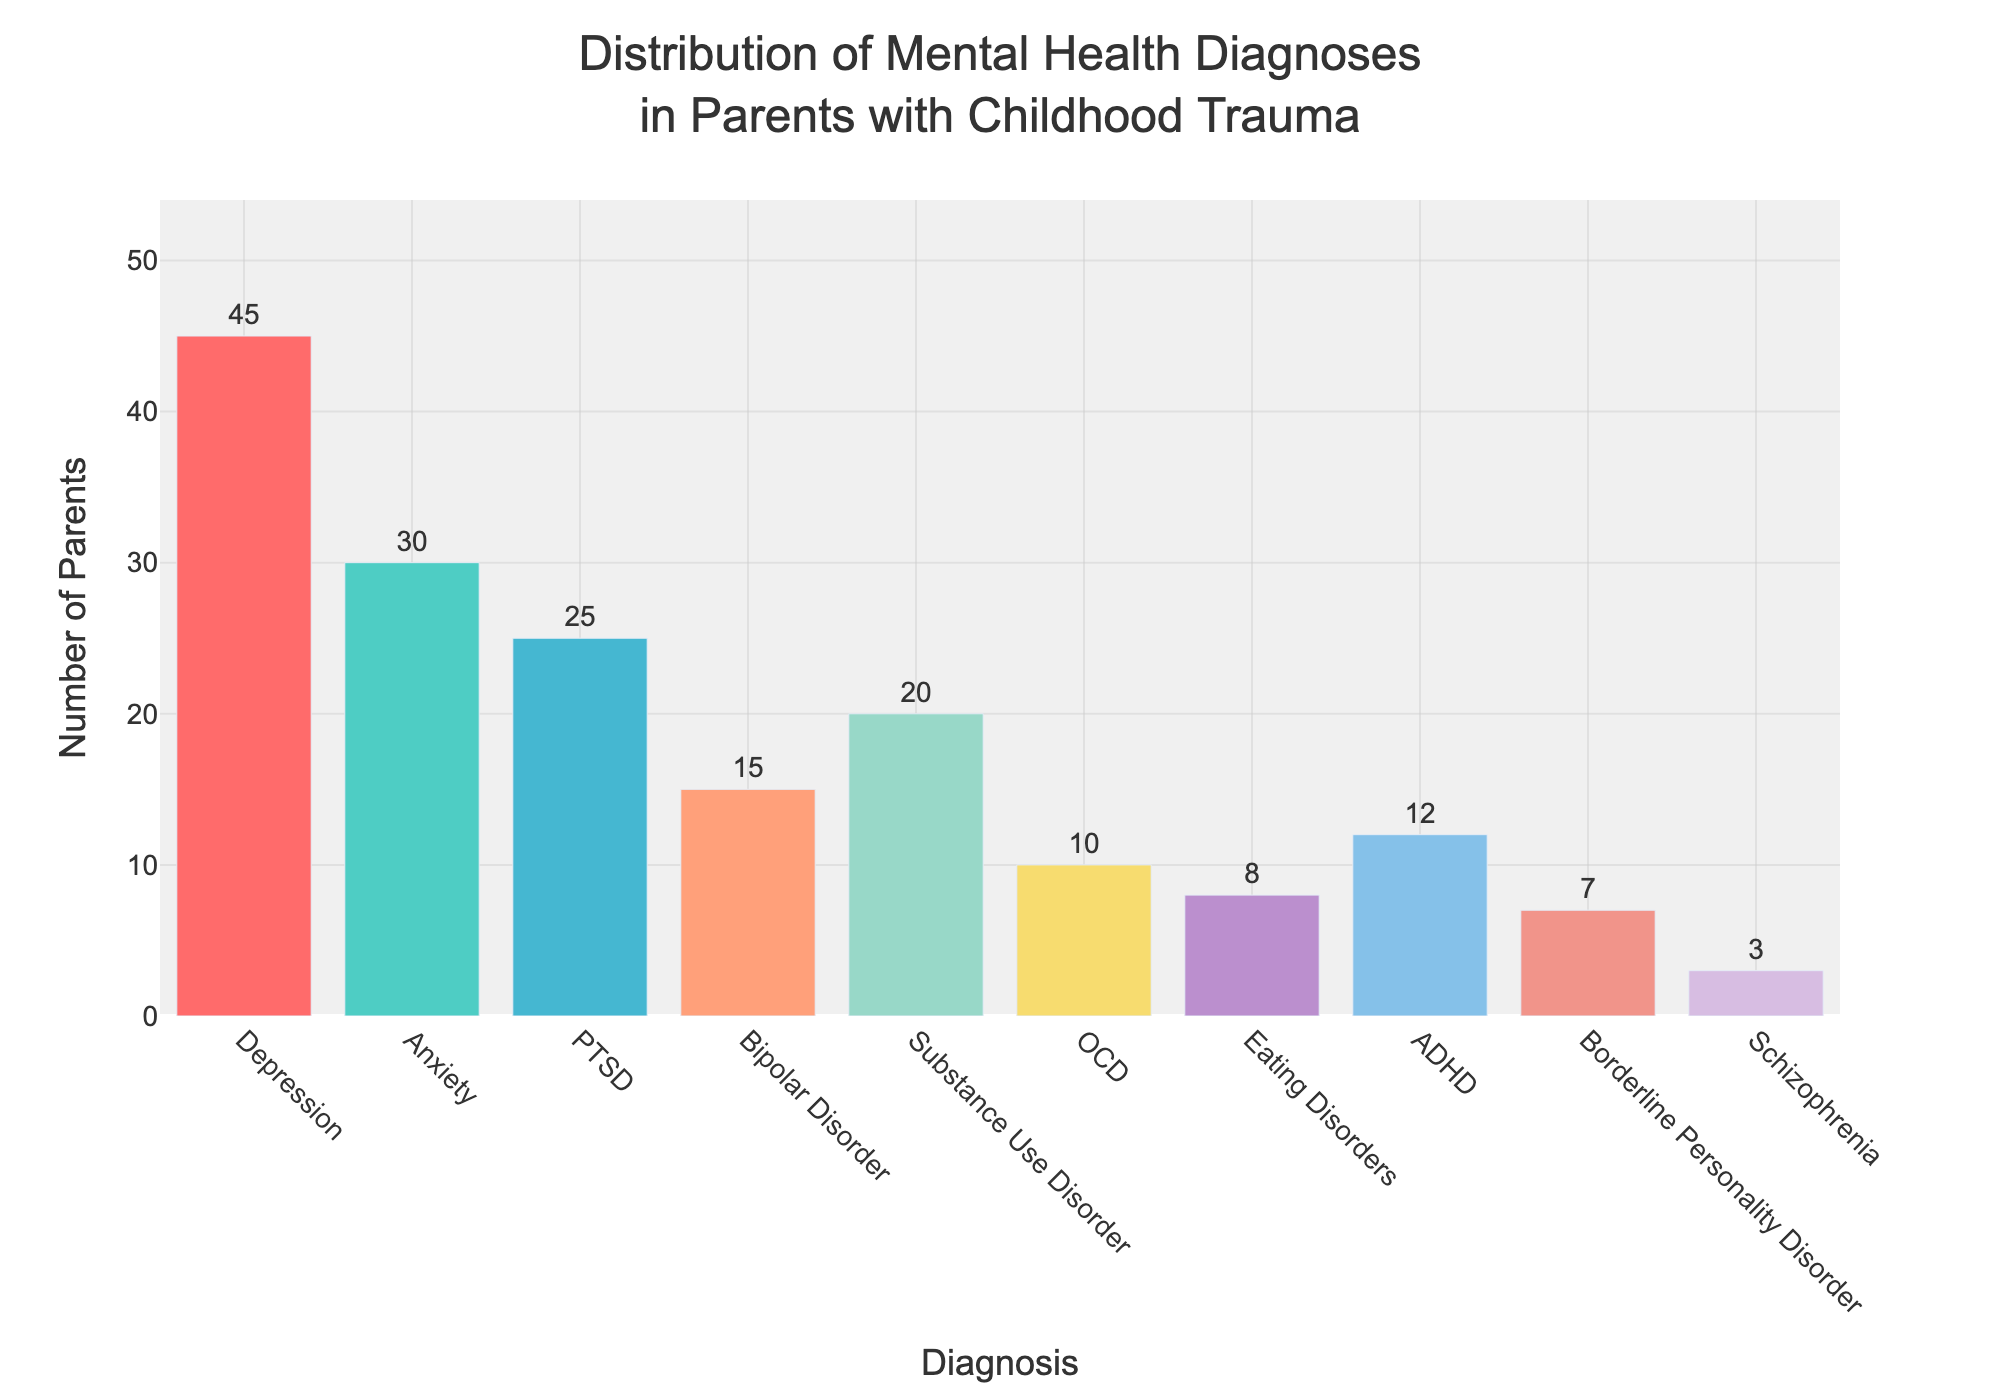What is the most common mental health diagnosis among parents who experienced childhood trauma? The most common mental health diagnosis can be identified by looking at the bar with the highest count. The bar labeled "Depression" is the tallest with a count of 45.
Answer: Depression How many diagnoses have a count of 20 or more parents? By examining the bars, we identify those with counts reaching or exceeding 20. These are "Depression" (45), "Anxiety" (30), PTSD (25), and "Substance Use Disorder" (20). There are four such diagnoses.
Answer: 4 What is the total number of parents represented in the figure? Sum all the counts of the diagnoses: 45 (Depression) + 30 (Anxiety) + 25 (PTSD) + 15 (Bipolar Disorder) + 20 (Substance Use Disorder) + 10 (OCD) + 8 (Eating Disorders) + 12 (ADHD) + 7 (Borderline Personality Disorder) + 3 (Schizophrenia) = 175.
Answer: 175 Which diagnosis has the lowest count of parents? Identify the shortest bar with the smallest count. The bar labeled "Schizophrenia" has the lowest count at 3.
Answer: Schizophrenia How many more parents are diagnosed with Depression compared to those diagnosed with Bipolar Disorder? Subtract the count of Bipolar Disorder (15) from that of Depression (45): 45 - 15 = 30.
Answer: 30 What is the average count of parents across all diagnoses? Calculate the average by summing all counts and dividing by the number of diagnoses: (45 + 30 + 25 + 15 + 20 + 10 + 8 + 12 + 7 + 3) / 10 = 175 / 10 = 17.5.
Answer: 17.5 How much greater is the count for Anxiety than for OCD? Subtract the count of OCD (10) from that of Anxiety (30): 30 - 10 = 20.
Answer: 20 Which diagnosis has a count closest to 10 parents? By examining the figure, the count for OCD is exactly 10.
Answer: OCD What is the total count for PTSD, Bipolar Disorder, and Substance Use Disorder combined? Add the counts of PTSD (25), Bipolar Disorder (15), and Substance Use Disorder (20): 25 + 15 + 20 = 60.
Answer: 60 Is the count for Borderline Personality Disorder more or less than half of the count for Anxiety? Calculate half of the count for Anxiety: 30 / 2 = 15, and compare it with the count for Borderline Personality Disorder (7). Since 7 is less than 15, it is less.
Answer: Less 